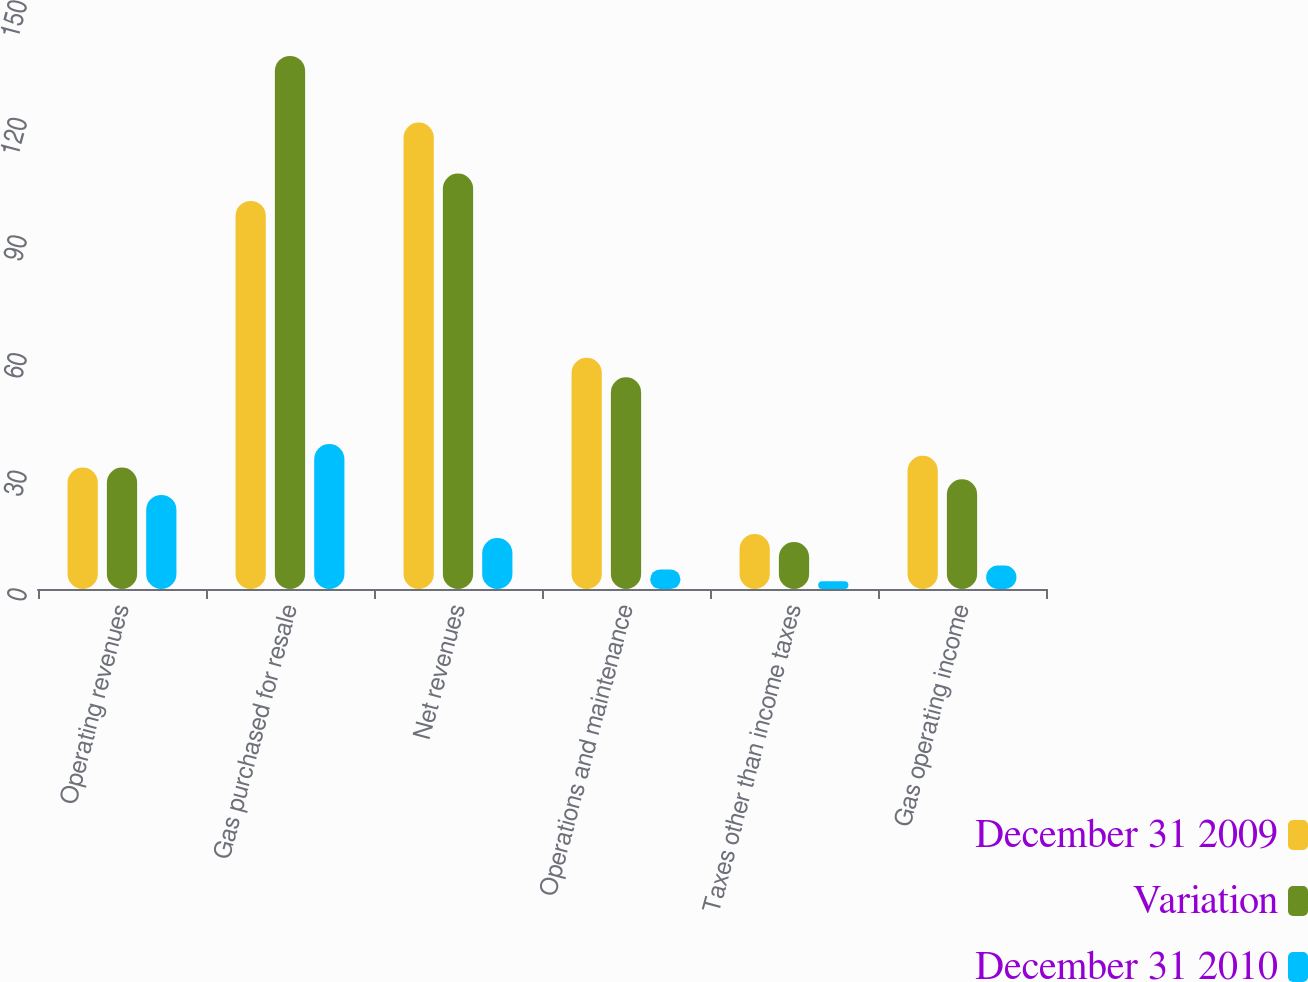Convert chart. <chart><loc_0><loc_0><loc_500><loc_500><stacked_bar_chart><ecel><fcel>Operating revenues<fcel>Gas purchased for resale<fcel>Net revenues<fcel>Operations and maintenance<fcel>Taxes other than income taxes<fcel>Gas operating income<nl><fcel>December 31 2009<fcel>31<fcel>99<fcel>119<fcel>59<fcel>14<fcel>34<nl><fcel>Variation<fcel>31<fcel>136<fcel>106<fcel>54<fcel>12<fcel>28<nl><fcel>December 31 2010<fcel>24<fcel>37<fcel>13<fcel>5<fcel>2<fcel>6<nl></chart> 